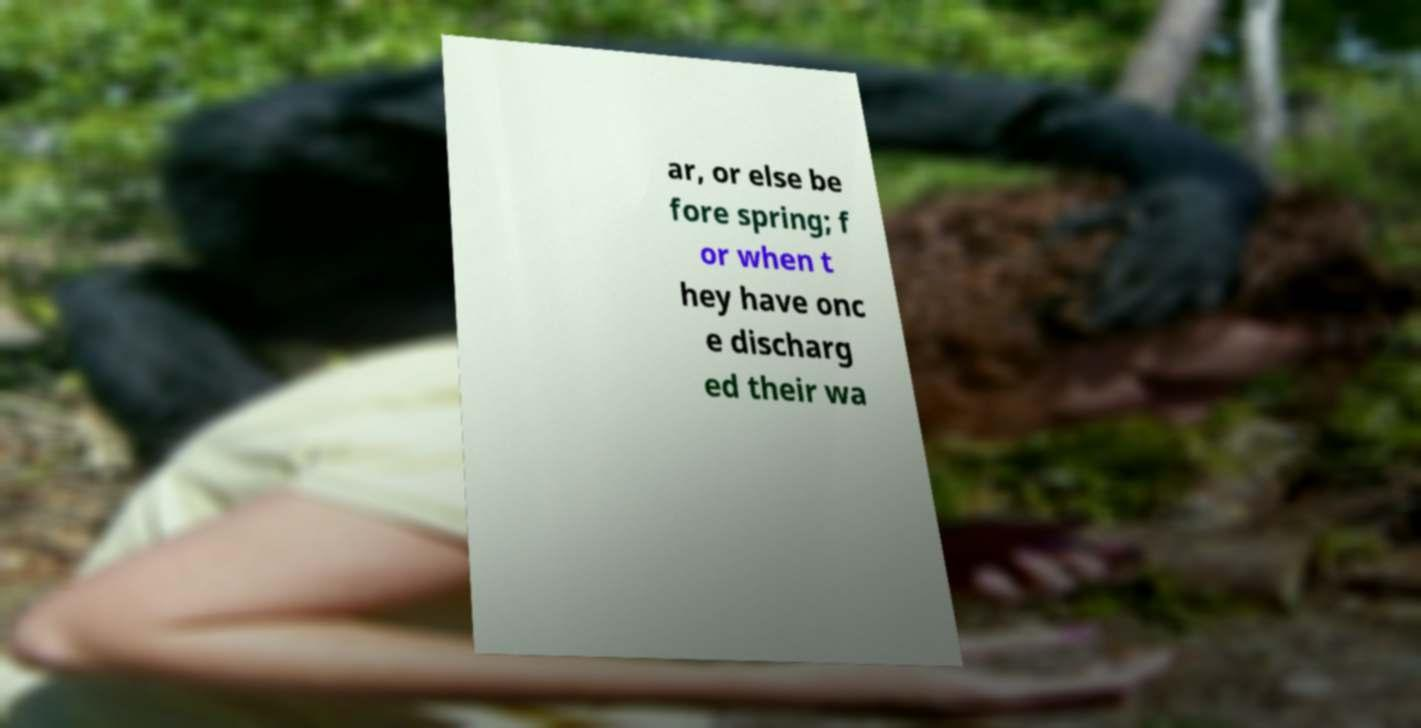I need the written content from this picture converted into text. Can you do that? ar, or else be fore spring; f or when t hey have onc e discharg ed their wa 